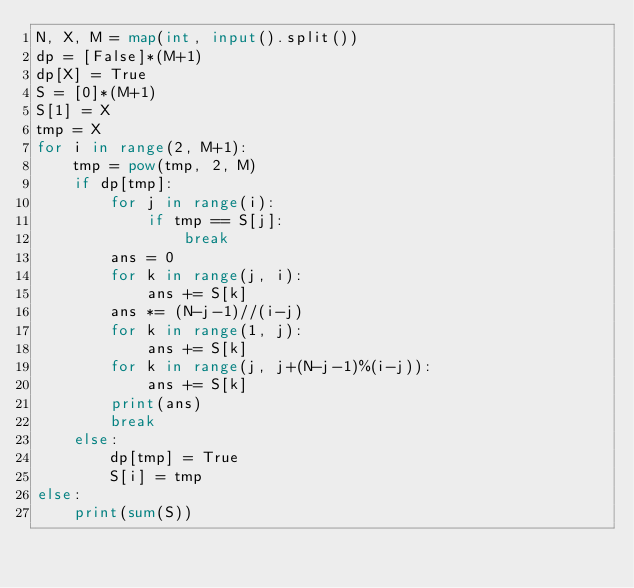Convert code to text. <code><loc_0><loc_0><loc_500><loc_500><_Python_>N, X, M = map(int, input().split())
dp = [False]*(M+1)
dp[X] = True
S = [0]*(M+1)
S[1] = X
tmp = X
for i in range(2, M+1):
    tmp = pow(tmp, 2, M)
    if dp[tmp]:
        for j in range(i):
            if tmp == S[j]:
                break
        ans = 0
        for k in range(j, i):
            ans += S[k]
        ans *= (N-j-1)//(i-j)
        for k in range(1, j):
            ans += S[k]
        for k in range(j, j+(N-j-1)%(i-j)):
            ans += S[k]
        print(ans)
        break
    else:
        dp[tmp] = True
        S[i] = tmp
else:
    print(sum(S))</code> 